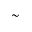Convert formula to latex. <formula><loc_0><loc_0><loc_500><loc_500>\sim</formula> 